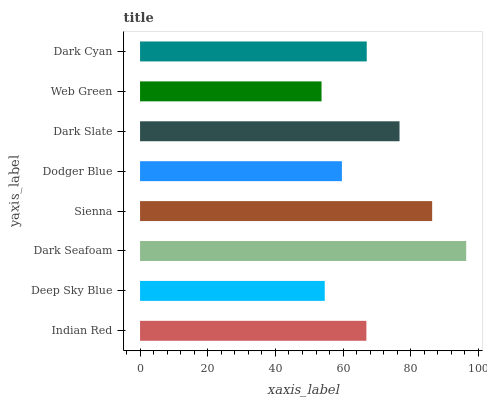Is Web Green the minimum?
Answer yes or no. Yes. Is Dark Seafoam the maximum?
Answer yes or no. Yes. Is Deep Sky Blue the minimum?
Answer yes or no. No. Is Deep Sky Blue the maximum?
Answer yes or no. No. Is Indian Red greater than Deep Sky Blue?
Answer yes or no. Yes. Is Deep Sky Blue less than Indian Red?
Answer yes or no. Yes. Is Deep Sky Blue greater than Indian Red?
Answer yes or no. No. Is Indian Red less than Deep Sky Blue?
Answer yes or no. No. Is Dark Cyan the high median?
Answer yes or no. Yes. Is Indian Red the low median?
Answer yes or no. Yes. Is Deep Sky Blue the high median?
Answer yes or no. No. Is Dark Cyan the low median?
Answer yes or no. No. 